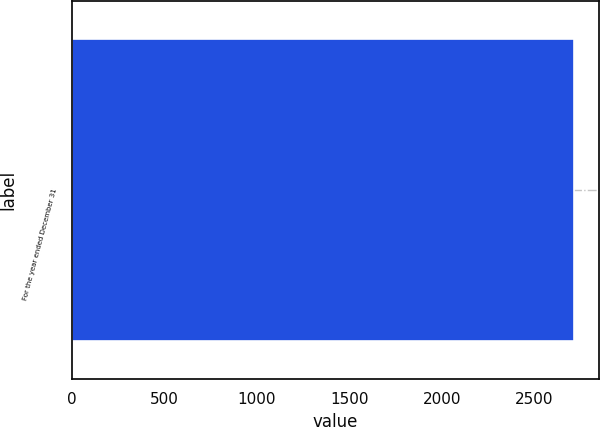Convert chart. <chart><loc_0><loc_0><loc_500><loc_500><bar_chart><fcel>For the year ended December 31<nl><fcel>2711<nl></chart> 